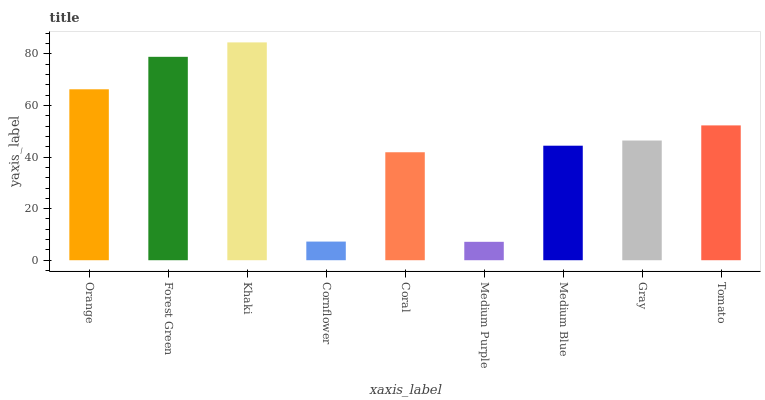Is Forest Green the minimum?
Answer yes or no. No. Is Forest Green the maximum?
Answer yes or no. No. Is Forest Green greater than Orange?
Answer yes or no. Yes. Is Orange less than Forest Green?
Answer yes or no. Yes. Is Orange greater than Forest Green?
Answer yes or no. No. Is Forest Green less than Orange?
Answer yes or no. No. Is Gray the high median?
Answer yes or no. Yes. Is Gray the low median?
Answer yes or no. Yes. Is Medium Purple the high median?
Answer yes or no. No. Is Orange the low median?
Answer yes or no. No. 